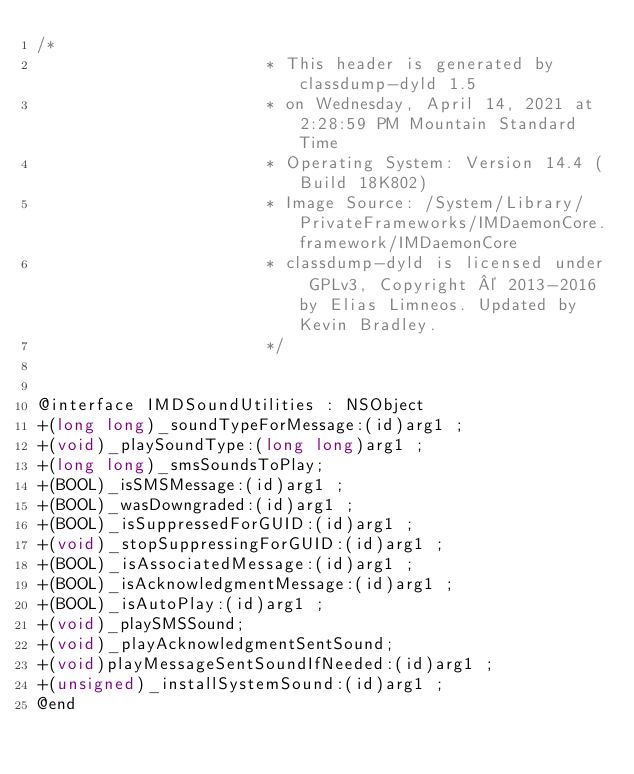Convert code to text. <code><loc_0><loc_0><loc_500><loc_500><_C_>/*
                       * This header is generated by classdump-dyld 1.5
                       * on Wednesday, April 14, 2021 at 2:28:59 PM Mountain Standard Time
                       * Operating System: Version 14.4 (Build 18K802)
                       * Image Source: /System/Library/PrivateFrameworks/IMDaemonCore.framework/IMDaemonCore
                       * classdump-dyld is licensed under GPLv3, Copyright © 2013-2016 by Elias Limneos. Updated by Kevin Bradley.
                       */


@interface IMDSoundUtilities : NSObject
+(long long)_soundTypeForMessage:(id)arg1 ;
+(void)_playSoundType:(long long)arg1 ;
+(long long)_smsSoundsToPlay;
+(BOOL)_isSMSMessage:(id)arg1 ;
+(BOOL)_wasDowngraded:(id)arg1 ;
+(BOOL)_isSuppressedForGUID:(id)arg1 ;
+(void)_stopSuppressingForGUID:(id)arg1 ;
+(BOOL)_isAssociatedMessage:(id)arg1 ;
+(BOOL)_isAcknowledgmentMessage:(id)arg1 ;
+(BOOL)_isAutoPlay:(id)arg1 ;
+(void)_playSMSSound;
+(void)_playAcknowledgmentSentSound;
+(void)playMessageSentSoundIfNeeded:(id)arg1 ;
+(unsigned)_installSystemSound:(id)arg1 ;
@end

</code> 